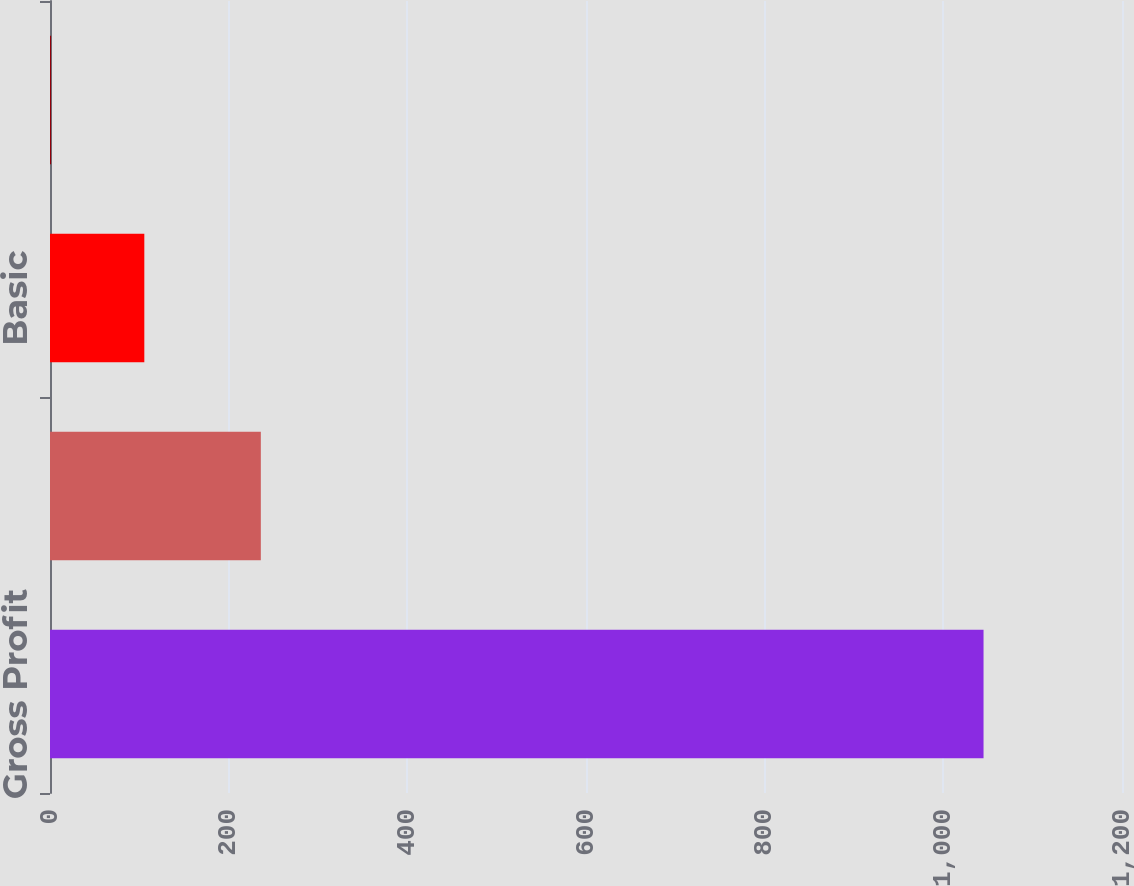Convert chart to OTSL. <chart><loc_0><loc_0><loc_500><loc_500><bar_chart><fcel>Gross Profit<fcel>Net Income<fcel>Basic<fcel>Diluted<nl><fcel>1045<fcel>236<fcel>105.58<fcel>1.2<nl></chart> 